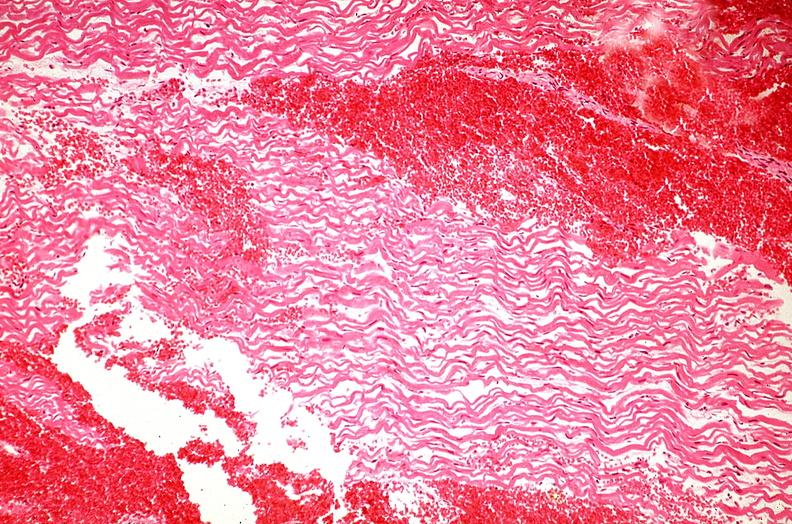does adenocarcinoma show heart, myocardial infarction, wavey fiber change, necrtosis, hemorrhage, and dissection?
Answer the question using a single word or phrase. No 